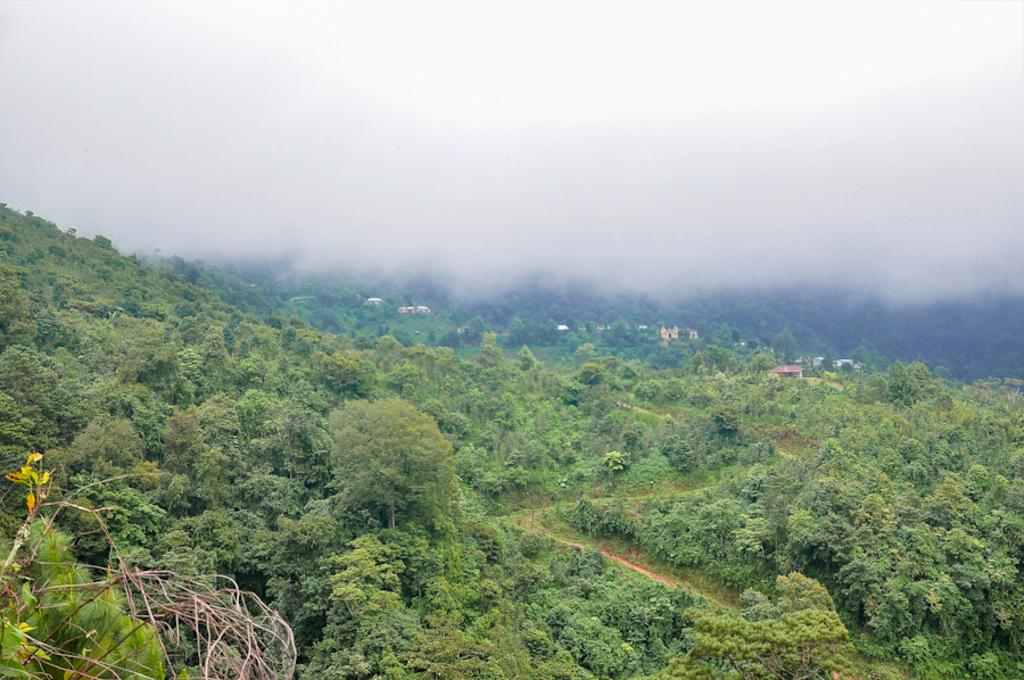What is located in the center of the image? There are trees in the center of the image. What can be seen in the background of the image? There is fog and buildings in the background of the image. What color is the tail of the balloon in the image? There is no balloon present in the image, so there is no tail to describe. 